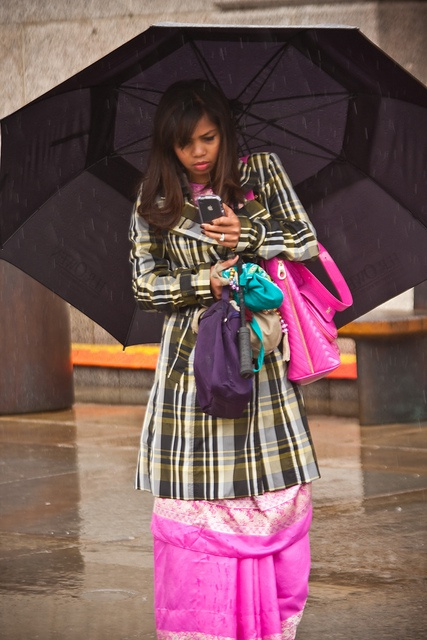Describe the objects in this image and their specific colors. I can see people in gray, black, violet, lightgray, and maroon tones, umbrella in gray, black, darkgray, and lightgray tones, handbag in gray, violet, magenta, and purple tones, and cell phone in gray, black, and darkgray tones in this image. 